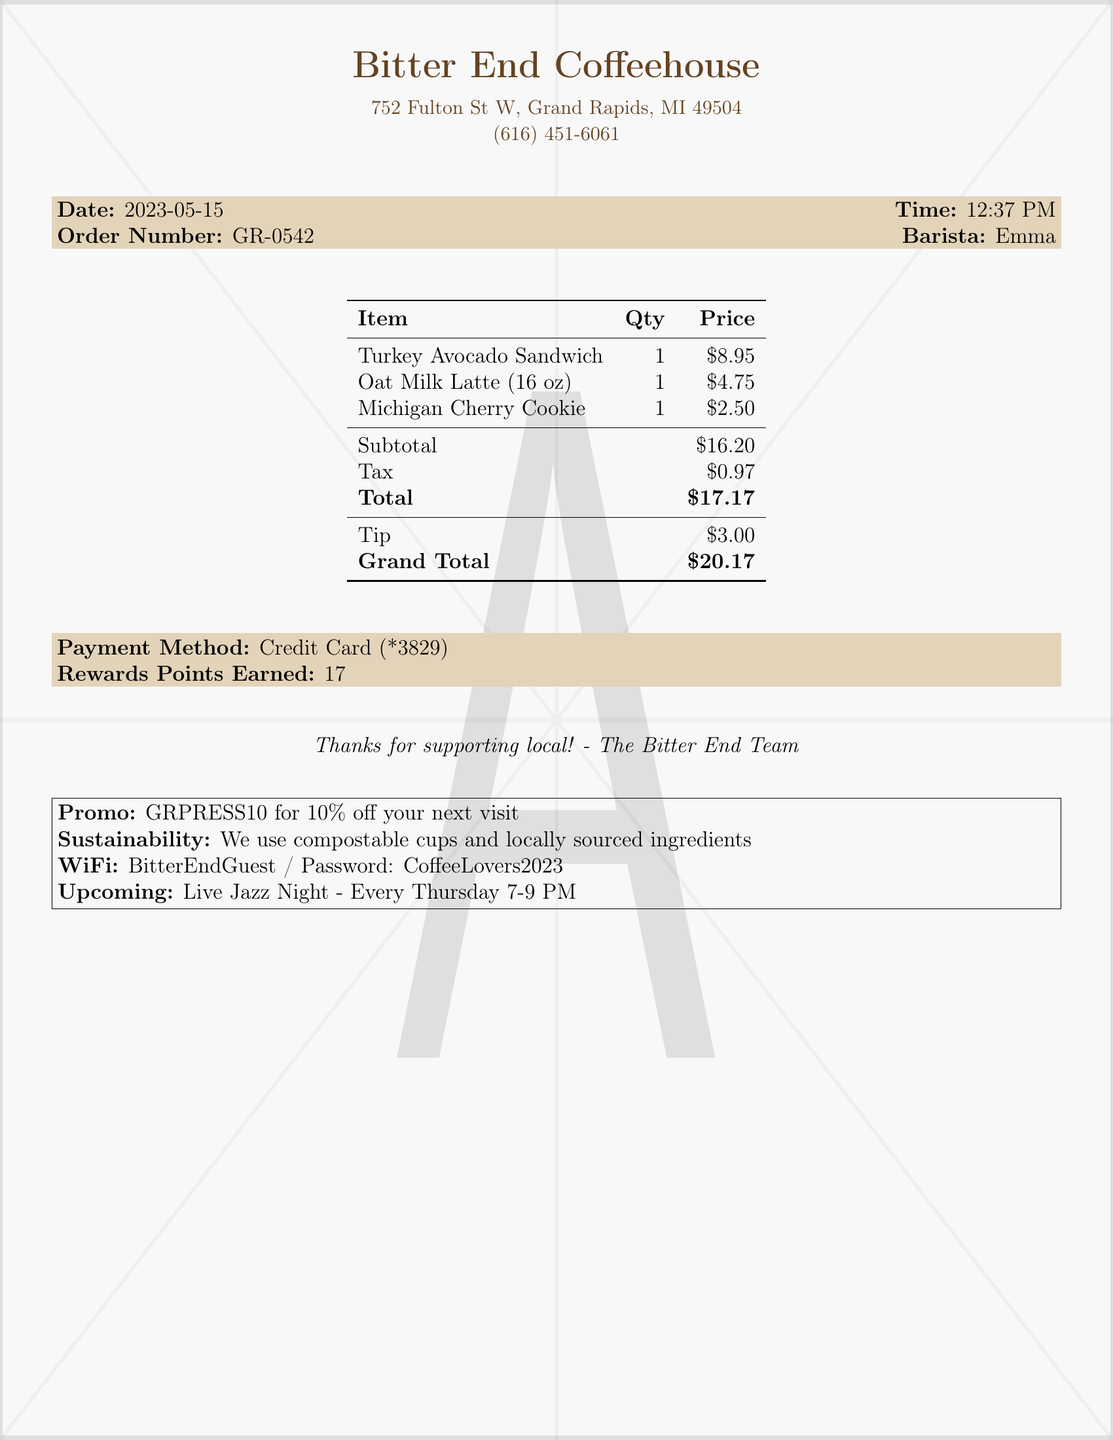What is the store name? The store name is listed at the top of the document.
Answer: Bitter End Coffeehouse What was the order number? The order number is specifically mentioned for reference.
Answer: GR-0542 Who was the barista that served the order? The barista's name is provided in the receipt.
Answer: Emma What is the total amount spent? The total amount is clearly indicated in the document.
Answer: $17.17 How much tax was charged? The tax amount is displayed separately in the document.
Answer: $0.97 What type of latte was ordered? The specific type of latte is mentioned in the items list.
Answer: Oat Milk Latte What was the tip amount? The tip amount is listed in the pricing section of the receipt.
Answer: $3.00 How many rewards points were earned? The rewards points earned are specified in the payment information section.
Answer: 17 What is the promo code mentioned? The promo code for a discount is provided at the bottom of the document.
Answer: GRPRESS10 for 10% off your next visit What event is mentioned as upcoming? The upcoming event is listed towards the end of the receipt.
Answer: Live Jazz Night - Every Thursday 7-9 PM 